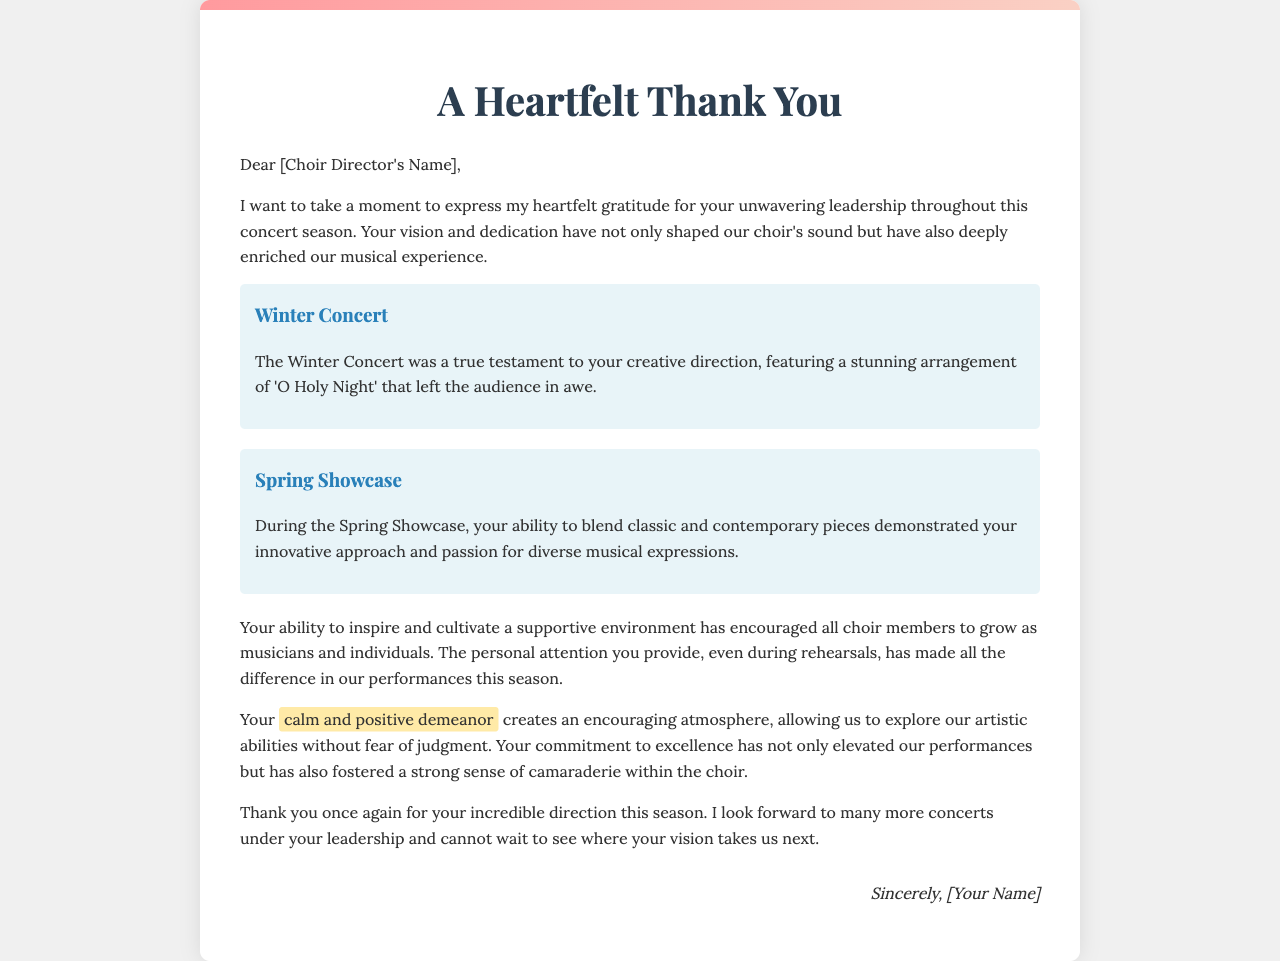What is the title of the letter? The title of the letter is prominently displayed at the top of the document.
Answer: A Heartfelt Thank You Who is the letter addressed to? The letter begins with a direct address to the choir director.
Answer: [Choir Director's Name] What song was featured in the Winter Concert? The document specifically mentions a song performed during the Winter Concert.
Answer: O Holy Night What was demonstrated during the Spring Showcase? The text refers to an aspect of the Spring Showcase that showcases the director's abilities.
Answer: Innovative approach What creates an encouraging atmosphere according to the letter? The text highlights a specific quality of the choir director that contributes to the environment.
Answer: Calm and positive demeanor What is the overall tone of the letter? The letter contains descriptive phrases that give insight into the mood conveyed throughout the text.
Answer: Heartfelt gratitude What does the author look forward to? The conclusion of the letter expresses anticipation for future events.
Answer: Many more concerts What is noted as having "made all the difference" in performances? The author credits a particular type of attention for the positive impact on performances.
Answer: Personal attention 